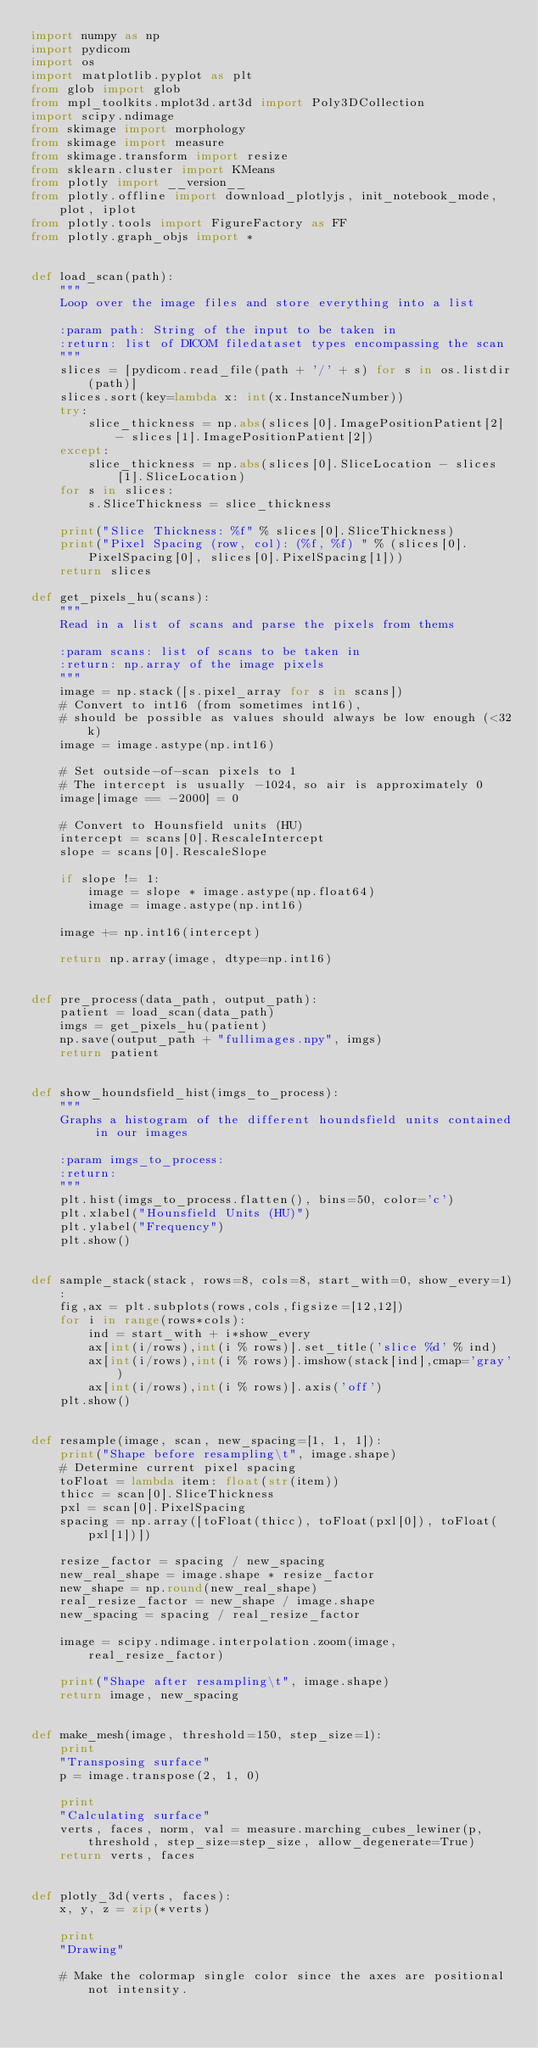<code> <loc_0><loc_0><loc_500><loc_500><_Python_>import numpy as np
import pydicom
import os
import matplotlib.pyplot as plt
from glob import glob
from mpl_toolkits.mplot3d.art3d import Poly3DCollection
import scipy.ndimage
from skimage import morphology
from skimage import measure
from skimage.transform import resize
from sklearn.cluster import KMeans
from plotly import __version__
from plotly.offline import download_plotlyjs, init_notebook_mode, plot, iplot
from plotly.tools import FigureFactory as FF
from plotly.graph_objs import *


def load_scan(path):
    """
    Loop over the image files and store everything into a list

    :param path: String of the input to be taken in
    :return: list of DICOM filedataset types encompassing the scan
    """
    slices = [pydicom.read_file(path + '/' + s) for s in os.listdir(path)]
    slices.sort(key=lambda x: int(x.InstanceNumber))
    try:
        slice_thickness = np.abs(slices[0].ImagePositionPatient[2] - slices[1].ImagePositionPatient[2])
    except:
        slice_thickness = np.abs(slices[0].SliceLocation - slices[1].SliceLocation)
    for s in slices:
        s.SliceThickness = slice_thickness

    print("Slice Thickness: %f" % slices[0].SliceThickness)
    print("Pixel Spacing (row, col): (%f, %f) " % (slices[0].PixelSpacing[0], slices[0].PixelSpacing[1]))
    return slices

def get_pixels_hu(scans):
    """
    Read in a list of scans and parse the pixels from thems

    :param scans: list of scans to be taken in
    :return: np.array of the image pixels
    """
    image = np.stack([s.pixel_array for s in scans])
    # Convert to int16 (from sometimes int16),
    # should be possible as values should always be low enough (<32k)
    image = image.astype(np.int16)

    # Set outside-of-scan pixels to 1
    # The intercept is usually -1024, so air is approximately 0
    image[image == -2000] = 0

    # Convert to Hounsfield units (HU)
    intercept = scans[0].RescaleIntercept
    slope = scans[0].RescaleSlope

    if slope != 1:
        image = slope * image.astype(np.float64)
        image = image.astype(np.int16)

    image += np.int16(intercept)

    return np.array(image, dtype=np.int16)


def pre_process(data_path, output_path):
    patient = load_scan(data_path)
    imgs = get_pixels_hu(patient)
    np.save(output_path + "fullimages.npy", imgs)
    return patient


def show_houndsfield_hist(imgs_to_process):
    """
    Graphs a histogram of the different houndsfield units contained in our images

    :param imgs_to_process:
    :return:
    """
    plt.hist(imgs_to_process.flatten(), bins=50, color='c')
    plt.xlabel("Hounsfield Units (HU)")
    plt.ylabel("Frequency")
    plt.show()


def sample_stack(stack, rows=8, cols=8, start_with=0, show_every=1):
    fig,ax = plt.subplots(rows,cols,figsize=[12,12])
    for i in range(rows*cols):
        ind = start_with + i*show_every
        ax[int(i/rows),int(i % rows)].set_title('slice %d' % ind)
        ax[int(i/rows),int(i % rows)].imshow(stack[ind],cmap='gray')
        ax[int(i/rows),int(i % rows)].axis('off')
    plt.show()


def resample(image, scan, new_spacing=[1, 1, 1]):
    print("Shape before resampling\t", image.shape)
    # Determine current pixel spacing
    toFloat = lambda item: float(str(item))
    thicc = scan[0].SliceThickness
    pxl = scan[0].PixelSpacing
    spacing = np.array([toFloat(thicc), toFloat(pxl[0]), toFloat(pxl[1])])

    resize_factor = spacing / new_spacing
    new_real_shape = image.shape * resize_factor
    new_shape = np.round(new_real_shape)
    real_resize_factor = new_shape / image.shape
    new_spacing = spacing / real_resize_factor

    image = scipy.ndimage.interpolation.zoom(image, real_resize_factor)

    print("Shape after resampling\t", image.shape)
    return image, new_spacing


def make_mesh(image, threshold=150, step_size=1):
    print
    "Transposing surface"
    p = image.transpose(2, 1, 0)

    print
    "Calculating surface"
    verts, faces, norm, val = measure.marching_cubes_lewiner(p, threshold, step_size=step_size, allow_degenerate=True)
    return verts, faces


def plotly_3d(verts, faces):
    x, y, z = zip(*verts)

    print
    "Drawing"

    # Make the colormap single color since the axes are positional not intensity.</code> 